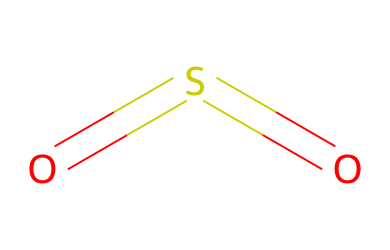What is the name of this chemical? The SMILES representation "O=S=O" denotes sulfur dioxide, where "S" refers to sulfur and "O" to oxygen, indicating the molecules involved in its composition.
Answer: sulfur dioxide How many oxygen atoms are in this molecule? Analyzing the SMILES notation, there are two "O" symbols present, indicating the presence of two oxygen atoms in the structure.
Answer: 2 What type of bonds are present between sulfur and oxygen? The structure "O=S=O" shows a double bond between each oxygen atom and the sulfur atom, as indicated by the "=" symbols, indicating that these are double bonds.
Answer: double bonds What is the oxidation state of sulfur in this compound? In sulfur dioxide, the oxidation state of sulfur can be calculated considering its bonding. Each oxygen is typically -2, and in total, there are two oxygen atoms contributing -4, thus sulfur must be +4 to balance the molecule.
Answer: +4 Is sulfur dioxide an electrolyte? The presence of ions in solution dictates whether a compound is an electrolyte. Sulfur dioxide can dissolve in water to form sulfurous acid, dissociating into ions, thus qualifying it as an electrolyte.
Answer: yes What is the primary role of sulfur dioxide in wine preservation? Sulfur dioxide acts as a preservative primarily due to its ability to inhibit the growth of bacteria and yeasts, preventing spoilage and oxidation, which is vital for maintaining wine quality.
Answer: preservative 